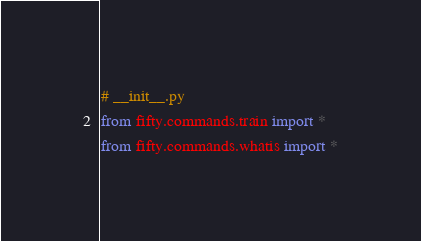<code> <loc_0><loc_0><loc_500><loc_500><_Python_># __init__.py
from fifty.commands.train import *
from fifty.commands.whatis import *
</code> 